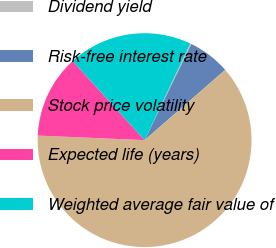Convert chart. <chart><loc_0><loc_0><loc_500><loc_500><pie_chart><fcel>Dividend yield<fcel>Risk-free interest rate<fcel>Stock price volatility<fcel>Expected life (years)<fcel>Weighted average fair value of<nl><fcel>0.19%<fcel>6.38%<fcel>62.09%<fcel>12.58%<fcel>18.77%<nl></chart> 